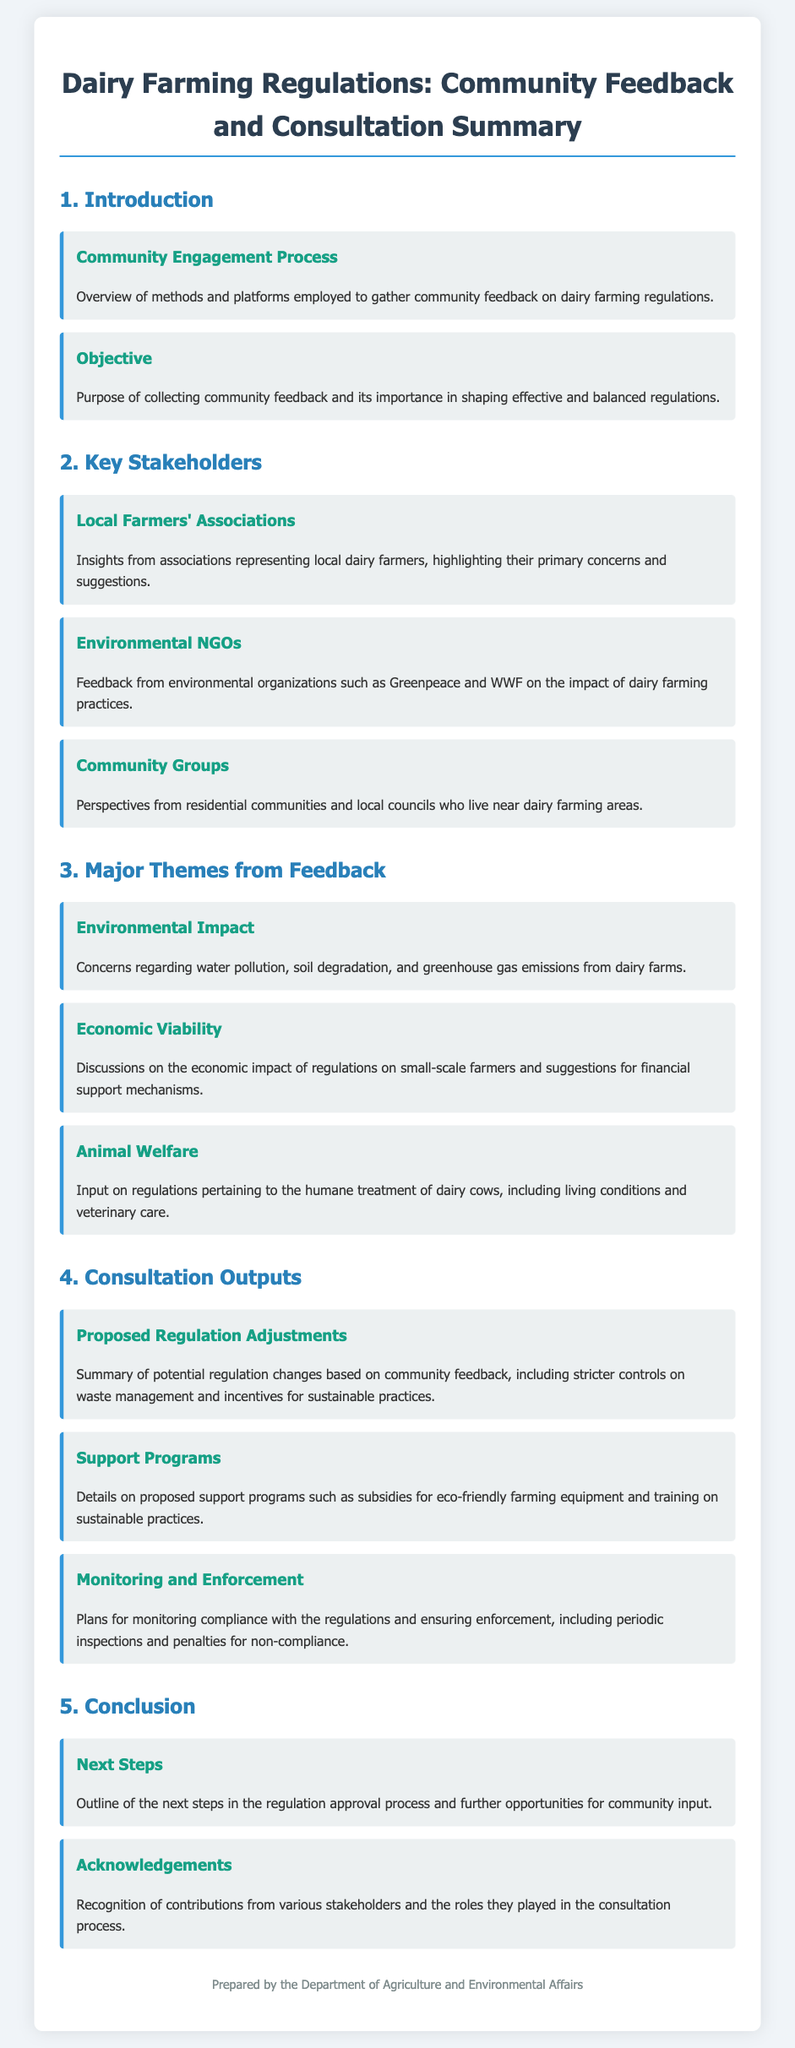What is the title of the document? The title of the document is found at the top of the introduction section, detailing the purpose of the content.
Answer: Dairy Farming Regulations: Community Feedback and Consultation Summary What is the main objective of collecting community feedback? The objective is explained to emphasize its importance in shaping regulations effectively and balance them.
Answer: Importance in shaping effective and balanced regulations Which organization provided feedback on environmental impacts? This answer is found under the key stakeholders, where specific organizations are mentioned for their insights.
Answer: Greenpeace and WWF What is a major concern regarding environmental impact? The document lists several environmental concerns, specifically highlighting one of them in the major themes section.
Answer: Water pollution How many proposed support programs are detailed in the consultation outputs? The number of distinct support programs can be counted in the respective section, which outlines various initiatives.
Answer: Two What are the next steps mentioned in the document? The document outlines planned actions following the consultation processes in the conclusion section.
Answer: Regulation approval process What is a key focus of feedback from local farmers' associations? The concerns raised by local farmers are mentioned in their section, providing a specific focus area.
Answer: Primary concerns and suggestions How are compliance and enforcement addressed in the document? The aspects of monitoring and enforcement are detailed in the consultation outputs, summarizing these plans.
Answer: Periodic inspections and penalties What type of feedback is summarized in the consultation outputs? The consultation outputs section summarizes the specific types of feedback received from community engagement.
Answer: Proposed Regulation Adjustments 